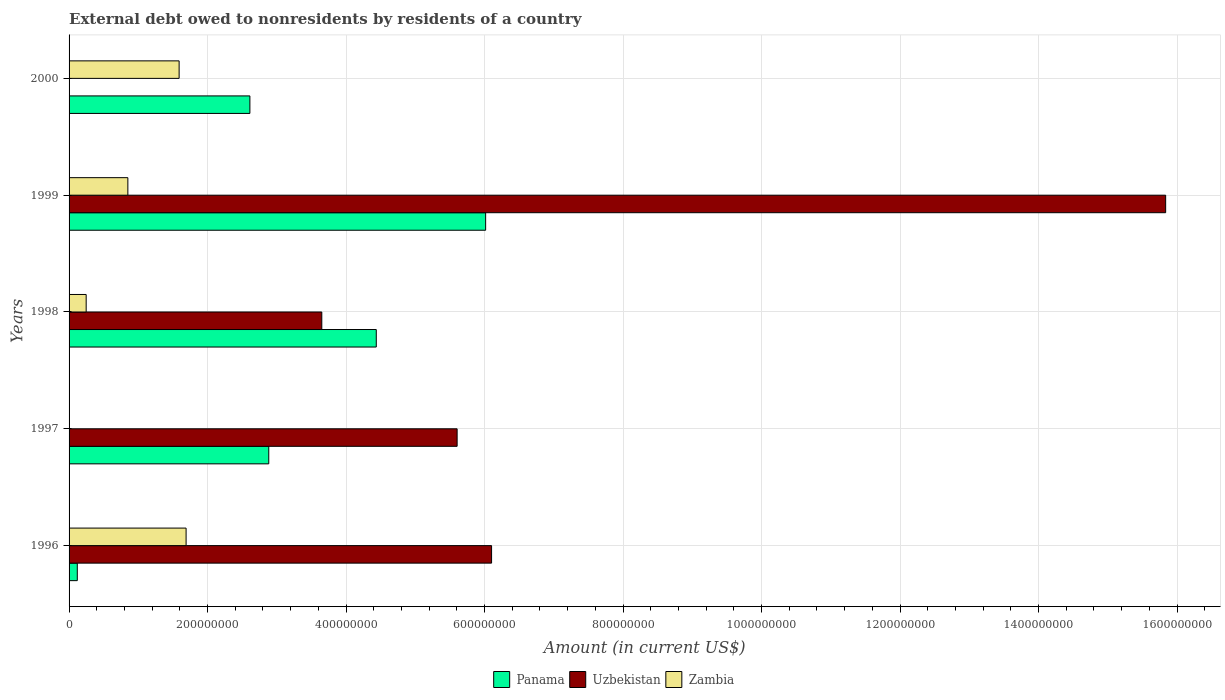How many different coloured bars are there?
Keep it short and to the point. 3. Are the number of bars per tick equal to the number of legend labels?
Offer a very short reply. No. How many bars are there on the 4th tick from the top?
Offer a terse response. 2. In how many cases, is the number of bars for a given year not equal to the number of legend labels?
Your response must be concise. 2. What is the external debt owed by residents in Panama in 1997?
Make the answer very short. 2.88e+08. Across all years, what is the maximum external debt owed by residents in Zambia?
Your response must be concise. 1.69e+08. Across all years, what is the minimum external debt owed by residents in Panama?
Give a very brief answer. 1.19e+07. What is the total external debt owed by residents in Zambia in the graph?
Your response must be concise. 4.38e+08. What is the difference between the external debt owed by residents in Panama in 1996 and that in 2000?
Give a very brief answer. -2.49e+08. What is the difference between the external debt owed by residents in Uzbekistan in 2000 and the external debt owed by residents in Zambia in 1998?
Your response must be concise. -2.47e+07. What is the average external debt owed by residents in Panama per year?
Provide a succinct answer. 3.21e+08. In the year 1996, what is the difference between the external debt owed by residents in Panama and external debt owed by residents in Uzbekistan?
Keep it short and to the point. -5.98e+08. In how many years, is the external debt owed by residents in Zambia greater than 1080000000 US$?
Offer a terse response. 0. What is the ratio of the external debt owed by residents in Zambia in 1998 to that in 1999?
Ensure brevity in your answer.  0.29. Is the external debt owed by residents in Panama in 1996 less than that in 1998?
Provide a short and direct response. Yes. Is the difference between the external debt owed by residents in Panama in 1996 and 1999 greater than the difference between the external debt owed by residents in Uzbekistan in 1996 and 1999?
Make the answer very short. Yes. What is the difference between the highest and the second highest external debt owed by residents in Panama?
Provide a succinct answer. 1.58e+08. What is the difference between the highest and the lowest external debt owed by residents in Zambia?
Keep it short and to the point. 1.69e+08. In how many years, is the external debt owed by residents in Panama greater than the average external debt owed by residents in Panama taken over all years?
Keep it short and to the point. 2. How many bars are there?
Make the answer very short. 13. Are all the bars in the graph horizontal?
Offer a very short reply. Yes. Are the values on the major ticks of X-axis written in scientific E-notation?
Provide a succinct answer. No. Does the graph contain any zero values?
Give a very brief answer. Yes. Where does the legend appear in the graph?
Your answer should be compact. Bottom center. How are the legend labels stacked?
Ensure brevity in your answer.  Horizontal. What is the title of the graph?
Offer a very short reply. External debt owed to nonresidents by residents of a country. What is the Amount (in current US$) in Panama in 1996?
Give a very brief answer. 1.19e+07. What is the Amount (in current US$) of Uzbekistan in 1996?
Your response must be concise. 6.10e+08. What is the Amount (in current US$) of Zambia in 1996?
Provide a short and direct response. 1.69e+08. What is the Amount (in current US$) in Panama in 1997?
Offer a very short reply. 2.88e+08. What is the Amount (in current US$) of Uzbekistan in 1997?
Your answer should be compact. 5.60e+08. What is the Amount (in current US$) of Panama in 1998?
Provide a succinct answer. 4.44e+08. What is the Amount (in current US$) in Uzbekistan in 1998?
Offer a terse response. 3.65e+08. What is the Amount (in current US$) in Zambia in 1998?
Provide a succinct answer. 2.47e+07. What is the Amount (in current US$) of Panama in 1999?
Your response must be concise. 6.02e+08. What is the Amount (in current US$) in Uzbekistan in 1999?
Your answer should be compact. 1.58e+09. What is the Amount (in current US$) in Zambia in 1999?
Your response must be concise. 8.49e+07. What is the Amount (in current US$) of Panama in 2000?
Give a very brief answer. 2.61e+08. What is the Amount (in current US$) in Uzbekistan in 2000?
Your answer should be compact. 0. What is the Amount (in current US$) of Zambia in 2000?
Ensure brevity in your answer.  1.59e+08. Across all years, what is the maximum Amount (in current US$) of Panama?
Your answer should be very brief. 6.02e+08. Across all years, what is the maximum Amount (in current US$) of Uzbekistan?
Provide a short and direct response. 1.58e+09. Across all years, what is the maximum Amount (in current US$) in Zambia?
Ensure brevity in your answer.  1.69e+08. Across all years, what is the minimum Amount (in current US$) in Panama?
Offer a very short reply. 1.19e+07. What is the total Amount (in current US$) in Panama in the graph?
Provide a short and direct response. 1.61e+09. What is the total Amount (in current US$) of Uzbekistan in the graph?
Ensure brevity in your answer.  3.12e+09. What is the total Amount (in current US$) in Zambia in the graph?
Your answer should be very brief. 4.38e+08. What is the difference between the Amount (in current US$) in Panama in 1996 and that in 1997?
Offer a very short reply. -2.76e+08. What is the difference between the Amount (in current US$) in Uzbekistan in 1996 and that in 1997?
Your answer should be very brief. 4.98e+07. What is the difference between the Amount (in current US$) in Panama in 1996 and that in 1998?
Offer a very short reply. -4.32e+08. What is the difference between the Amount (in current US$) in Uzbekistan in 1996 and that in 1998?
Your response must be concise. 2.45e+08. What is the difference between the Amount (in current US$) of Zambia in 1996 and that in 1998?
Provide a succinct answer. 1.44e+08. What is the difference between the Amount (in current US$) in Panama in 1996 and that in 1999?
Keep it short and to the point. -5.90e+08. What is the difference between the Amount (in current US$) in Uzbekistan in 1996 and that in 1999?
Your answer should be compact. -9.73e+08. What is the difference between the Amount (in current US$) of Zambia in 1996 and that in 1999?
Offer a terse response. 8.41e+07. What is the difference between the Amount (in current US$) of Panama in 1996 and that in 2000?
Provide a succinct answer. -2.49e+08. What is the difference between the Amount (in current US$) of Zambia in 1996 and that in 2000?
Your response must be concise. 1.01e+07. What is the difference between the Amount (in current US$) of Panama in 1997 and that in 1998?
Provide a short and direct response. -1.55e+08. What is the difference between the Amount (in current US$) in Uzbekistan in 1997 and that in 1998?
Your answer should be very brief. 1.95e+08. What is the difference between the Amount (in current US$) of Panama in 1997 and that in 1999?
Your answer should be very brief. -3.13e+08. What is the difference between the Amount (in current US$) in Uzbekistan in 1997 and that in 1999?
Make the answer very short. -1.02e+09. What is the difference between the Amount (in current US$) of Panama in 1997 and that in 2000?
Offer a very short reply. 2.72e+07. What is the difference between the Amount (in current US$) of Panama in 1998 and that in 1999?
Offer a terse response. -1.58e+08. What is the difference between the Amount (in current US$) of Uzbekistan in 1998 and that in 1999?
Make the answer very short. -1.22e+09. What is the difference between the Amount (in current US$) in Zambia in 1998 and that in 1999?
Provide a succinct answer. -6.02e+07. What is the difference between the Amount (in current US$) of Panama in 1998 and that in 2000?
Give a very brief answer. 1.83e+08. What is the difference between the Amount (in current US$) in Zambia in 1998 and that in 2000?
Your response must be concise. -1.34e+08. What is the difference between the Amount (in current US$) in Panama in 1999 and that in 2000?
Provide a succinct answer. 3.40e+08. What is the difference between the Amount (in current US$) in Zambia in 1999 and that in 2000?
Your answer should be compact. -7.40e+07. What is the difference between the Amount (in current US$) in Panama in 1996 and the Amount (in current US$) in Uzbekistan in 1997?
Offer a terse response. -5.49e+08. What is the difference between the Amount (in current US$) of Panama in 1996 and the Amount (in current US$) of Uzbekistan in 1998?
Your response must be concise. -3.53e+08. What is the difference between the Amount (in current US$) of Panama in 1996 and the Amount (in current US$) of Zambia in 1998?
Provide a short and direct response. -1.28e+07. What is the difference between the Amount (in current US$) of Uzbekistan in 1996 and the Amount (in current US$) of Zambia in 1998?
Make the answer very short. 5.85e+08. What is the difference between the Amount (in current US$) of Panama in 1996 and the Amount (in current US$) of Uzbekistan in 1999?
Ensure brevity in your answer.  -1.57e+09. What is the difference between the Amount (in current US$) of Panama in 1996 and the Amount (in current US$) of Zambia in 1999?
Make the answer very short. -7.30e+07. What is the difference between the Amount (in current US$) of Uzbekistan in 1996 and the Amount (in current US$) of Zambia in 1999?
Your answer should be compact. 5.25e+08. What is the difference between the Amount (in current US$) of Panama in 1996 and the Amount (in current US$) of Zambia in 2000?
Offer a very short reply. -1.47e+08. What is the difference between the Amount (in current US$) of Uzbekistan in 1996 and the Amount (in current US$) of Zambia in 2000?
Ensure brevity in your answer.  4.51e+08. What is the difference between the Amount (in current US$) in Panama in 1997 and the Amount (in current US$) in Uzbekistan in 1998?
Make the answer very short. -7.66e+07. What is the difference between the Amount (in current US$) in Panama in 1997 and the Amount (in current US$) in Zambia in 1998?
Provide a succinct answer. 2.64e+08. What is the difference between the Amount (in current US$) of Uzbekistan in 1997 and the Amount (in current US$) of Zambia in 1998?
Give a very brief answer. 5.36e+08. What is the difference between the Amount (in current US$) in Panama in 1997 and the Amount (in current US$) in Uzbekistan in 1999?
Keep it short and to the point. -1.30e+09. What is the difference between the Amount (in current US$) in Panama in 1997 and the Amount (in current US$) in Zambia in 1999?
Offer a terse response. 2.03e+08. What is the difference between the Amount (in current US$) of Uzbekistan in 1997 and the Amount (in current US$) of Zambia in 1999?
Offer a very short reply. 4.75e+08. What is the difference between the Amount (in current US$) of Panama in 1997 and the Amount (in current US$) of Zambia in 2000?
Keep it short and to the point. 1.29e+08. What is the difference between the Amount (in current US$) of Uzbekistan in 1997 and the Amount (in current US$) of Zambia in 2000?
Provide a succinct answer. 4.01e+08. What is the difference between the Amount (in current US$) of Panama in 1998 and the Amount (in current US$) of Uzbekistan in 1999?
Give a very brief answer. -1.14e+09. What is the difference between the Amount (in current US$) of Panama in 1998 and the Amount (in current US$) of Zambia in 1999?
Offer a terse response. 3.59e+08. What is the difference between the Amount (in current US$) of Uzbekistan in 1998 and the Amount (in current US$) of Zambia in 1999?
Provide a succinct answer. 2.80e+08. What is the difference between the Amount (in current US$) of Panama in 1998 and the Amount (in current US$) of Zambia in 2000?
Your response must be concise. 2.85e+08. What is the difference between the Amount (in current US$) in Uzbekistan in 1998 and the Amount (in current US$) in Zambia in 2000?
Give a very brief answer. 2.06e+08. What is the difference between the Amount (in current US$) of Panama in 1999 and the Amount (in current US$) of Zambia in 2000?
Provide a short and direct response. 4.43e+08. What is the difference between the Amount (in current US$) in Uzbekistan in 1999 and the Amount (in current US$) in Zambia in 2000?
Provide a succinct answer. 1.42e+09. What is the average Amount (in current US$) of Panama per year?
Your response must be concise. 3.21e+08. What is the average Amount (in current US$) of Uzbekistan per year?
Your answer should be compact. 6.24e+08. What is the average Amount (in current US$) of Zambia per year?
Your response must be concise. 8.75e+07. In the year 1996, what is the difference between the Amount (in current US$) in Panama and Amount (in current US$) in Uzbekistan?
Give a very brief answer. -5.98e+08. In the year 1996, what is the difference between the Amount (in current US$) of Panama and Amount (in current US$) of Zambia?
Provide a short and direct response. -1.57e+08. In the year 1996, what is the difference between the Amount (in current US$) in Uzbekistan and Amount (in current US$) in Zambia?
Offer a very short reply. 4.41e+08. In the year 1997, what is the difference between the Amount (in current US$) in Panama and Amount (in current US$) in Uzbekistan?
Your answer should be very brief. -2.72e+08. In the year 1998, what is the difference between the Amount (in current US$) of Panama and Amount (in current US$) of Uzbekistan?
Provide a succinct answer. 7.87e+07. In the year 1998, what is the difference between the Amount (in current US$) in Panama and Amount (in current US$) in Zambia?
Your response must be concise. 4.19e+08. In the year 1998, what is the difference between the Amount (in current US$) of Uzbekistan and Amount (in current US$) of Zambia?
Your answer should be very brief. 3.40e+08. In the year 1999, what is the difference between the Amount (in current US$) in Panama and Amount (in current US$) in Uzbekistan?
Ensure brevity in your answer.  -9.82e+08. In the year 1999, what is the difference between the Amount (in current US$) of Panama and Amount (in current US$) of Zambia?
Provide a short and direct response. 5.17e+08. In the year 1999, what is the difference between the Amount (in current US$) of Uzbekistan and Amount (in current US$) of Zambia?
Provide a short and direct response. 1.50e+09. In the year 2000, what is the difference between the Amount (in current US$) of Panama and Amount (in current US$) of Zambia?
Your answer should be very brief. 1.02e+08. What is the ratio of the Amount (in current US$) in Panama in 1996 to that in 1997?
Your answer should be very brief. 0.04. What is the ratio of the Amount (in current US$) of Uzbekistan in 1996 to that in 1997?
Offer a terse response. 1.09. What is the ratio of the Amount (in current US$) in Panama in 1996 to that in 1998?
Your answer should be compact. 0.03. What is the ratio of the Amount (in current US$) in Uzbekistan in 1996 to that in 1998?
Your answer should be compact. 1.67. What is the ratio of the Amount (in current US$) in Zambia in 1996 to that in 1998?
Provide a short and direct response. 6.84. What is the ratio of the Amount (in current US$) in Panama in 1996 to that in 1999?
Your response must be concise. 0.02. What is the ratio of the Amount (in current US$) of Uzbekistan in 1996 to that in 1999?
Keep it short and to the point. 0.39. What is the ratio of the Amount (in current US$) in Zambia in 1996 to that in 1999?
Your answer should be very brief. 1.99. What is the ratio of the Amount (in current US$) of Panama in 1996 to that in 2000?
Your response must be concise. 0.05. What is the ratio of the Amount (in current US$) in Zambia in 1996 to that in 2000?
Keep it short and to the point. 1.06. What is the ratio of the Amount (in current US$) of Panama in 1997 to that in 1998?
Your answer should be compact. 0.65. What is the ratio of the Amount (in current US$) in Uzbekistan in 1997 to that in 1998?
Ensure brevity in your answer.  1.54. What is the ratio of the Amount (in current US$) in Panama in 1997 to that in 1999?
Keep it short and to the point. 0.48. What is the ratio of the Amount (in current US$) of Uzbekistan in 1997 to that in 1999?
Your response must be concise. 0.35. What is the ratio of the Amount (in current US$) in Panama in 1997 to that in 2000?
Ensure brevity in your answer.  1.1. What is the ratio of the Amount (in current US$) in Panama in 1998 to that in 1999?
Provide a short and direct response. 0.74. What is the ratio of the Amount (in current US$) in Uzbekistan in 1998 to that in 1999?
Offer a very short reply. 0.23. What is the ratio of the Amount (in current US$) of Zambia in 1998 to that in 1999?
Offer a terse response. 0.29. What is the ratio of the Amount (in current US$) in Panama in 1998 to that in 2000?
Offer a terse response. 1.7. What is the ratio of the Amount (in current US$) in Zambia in 1998 to that in 2000?
Offer a terse response. 0.16. What is the ratio of the Amount (in current US$) of Panama in 1999 to that in 2000?
Your response must be concise. 2.3. What is the ratio of the Amount (in current US$) of Zambia in 1999 to that in 2000?
Provide a succinct answer. 0.53. What is the difference between the highest and the second highest Amount (in current US$) in Panama?
Your answer should be very brief. 1.58e+08. What is the difference between the highest and the second highest Amount (in current US$) of Uzbekistan?
Ensure brevity in your answer.  9.73e+08. What is the difference between the highest and the second highest Amount (in current US$) of Zambia?
Your response must be concise. 1.01e+07. What is the difference between the highest and the lowest Amount (in current US$) in Panama?
Make the answer very short. 5.90e+08. What is the difference between the highest and the lowest Amount (in current US$) in Uzbekistan?
Make the answer very short. 1.58e+09. What is the difference between the highest and the lowest Amount (in current US$) of Zambia?
Ensure brevity in your answer.  1.69e+08. 